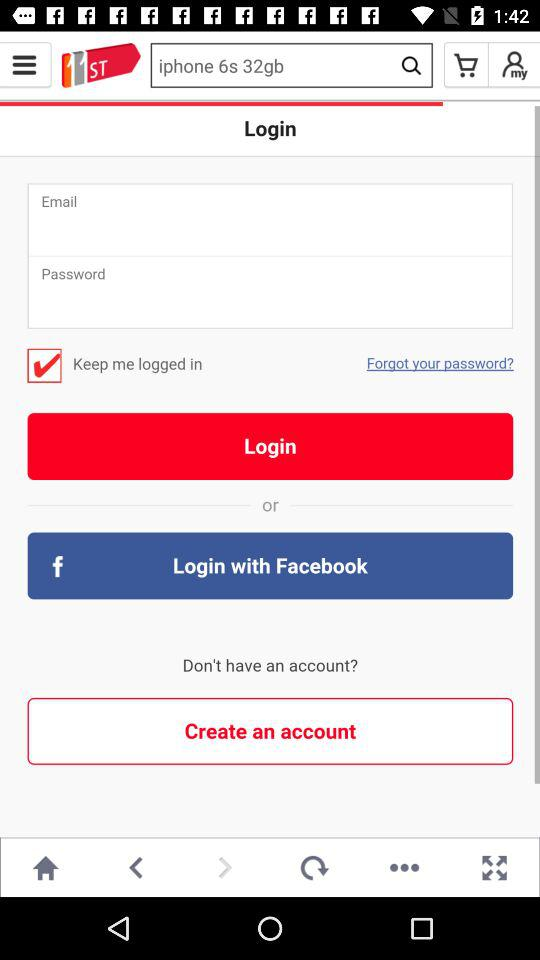What's the total number of slides? The total number of slides is 14. 